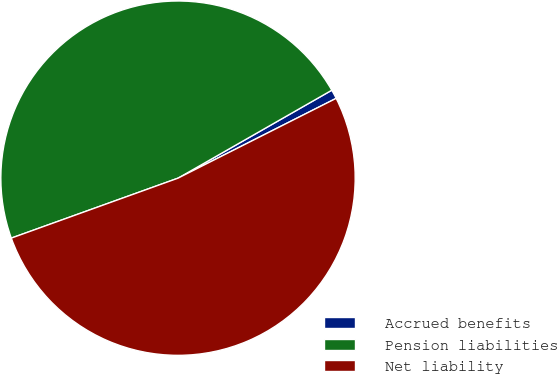Convert chart. <chart><loc_0><loc_0><loc_500><loc_500><pie_chart><fcel>Accrued benefits<fcel>Pension liabilities<fcel>Net liability<nl><fcel>0.83%<fcel>47.22%<fcel>51.94%<nl></chart> 